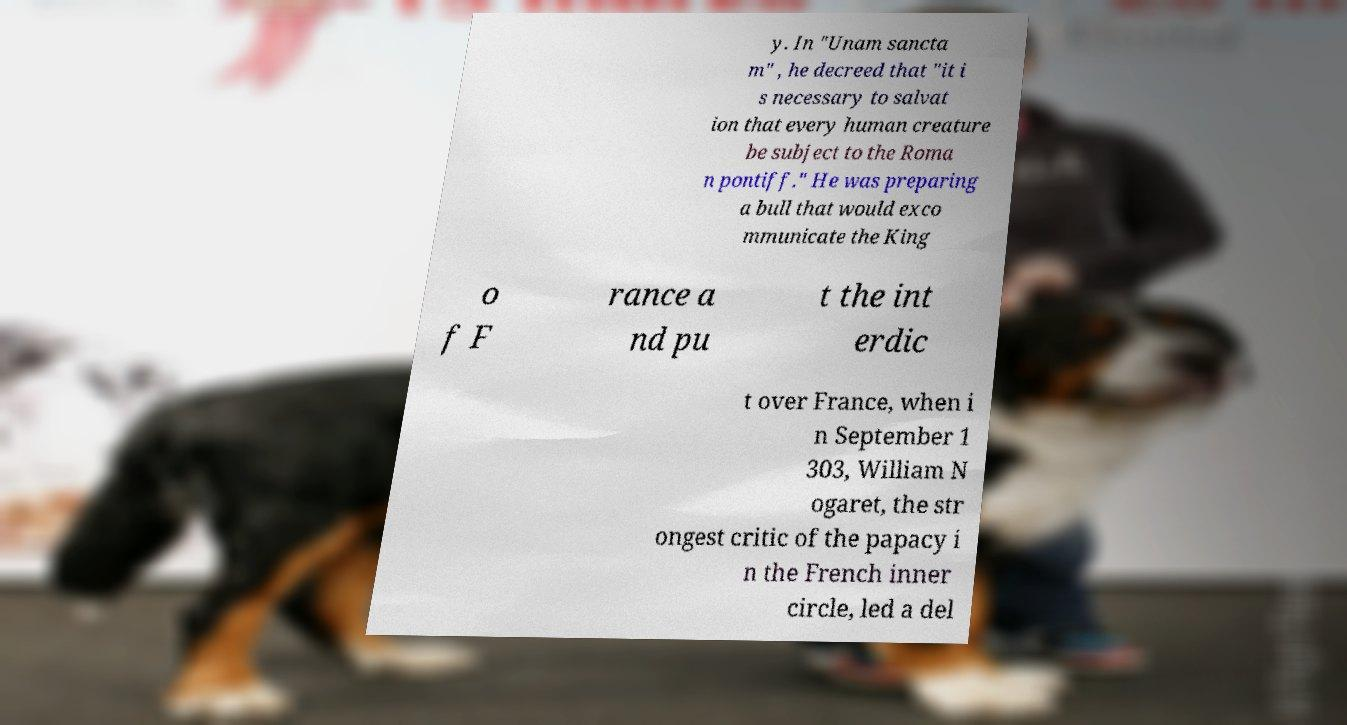Could you extract and type out the text from this image? y. In "Unam sancta m" , he decreed that "it i s necessary to salvat ion that every human creature be subject to the Roma n pontiff." He was preparing a bull that would exco mmunicate the King o f F rance a nd pu t the int erdic t over France, when i n September 1 303, William N ogaret, the str ongest critic of the papacy i n the French inner circle, led a del 